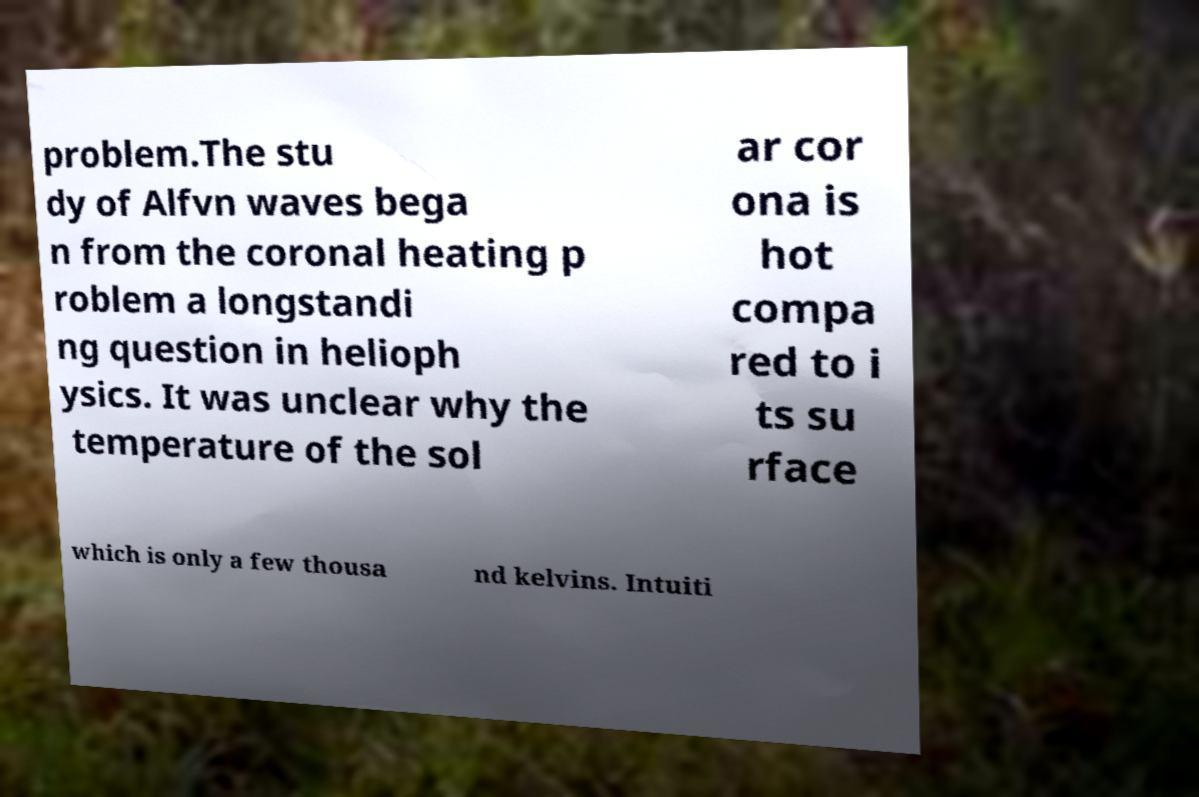I need the written content from this picture converted into text. Can you do that? problem.The stu dy of Alfvn waves bega n from the coronal heating p roblem a longstandi ng question in helioph ysics. It was unclear why the temperature of the sol ar cor ona is hot compa red to i ts su rface which is only a few thousa nd kelvins. Intuiti 